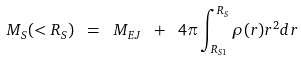Convert formula to latex. <formula><loc_0><loc_0><loc_500><loc_500>M _ { S } ( < R _ { S } ) \ = \ M _ { E J } \ + \ 4 \pi \int _ { R _ { S 1 } } ^ { R _ { S } } \rho ( r ) r ^ { 2 } d r</formula> 